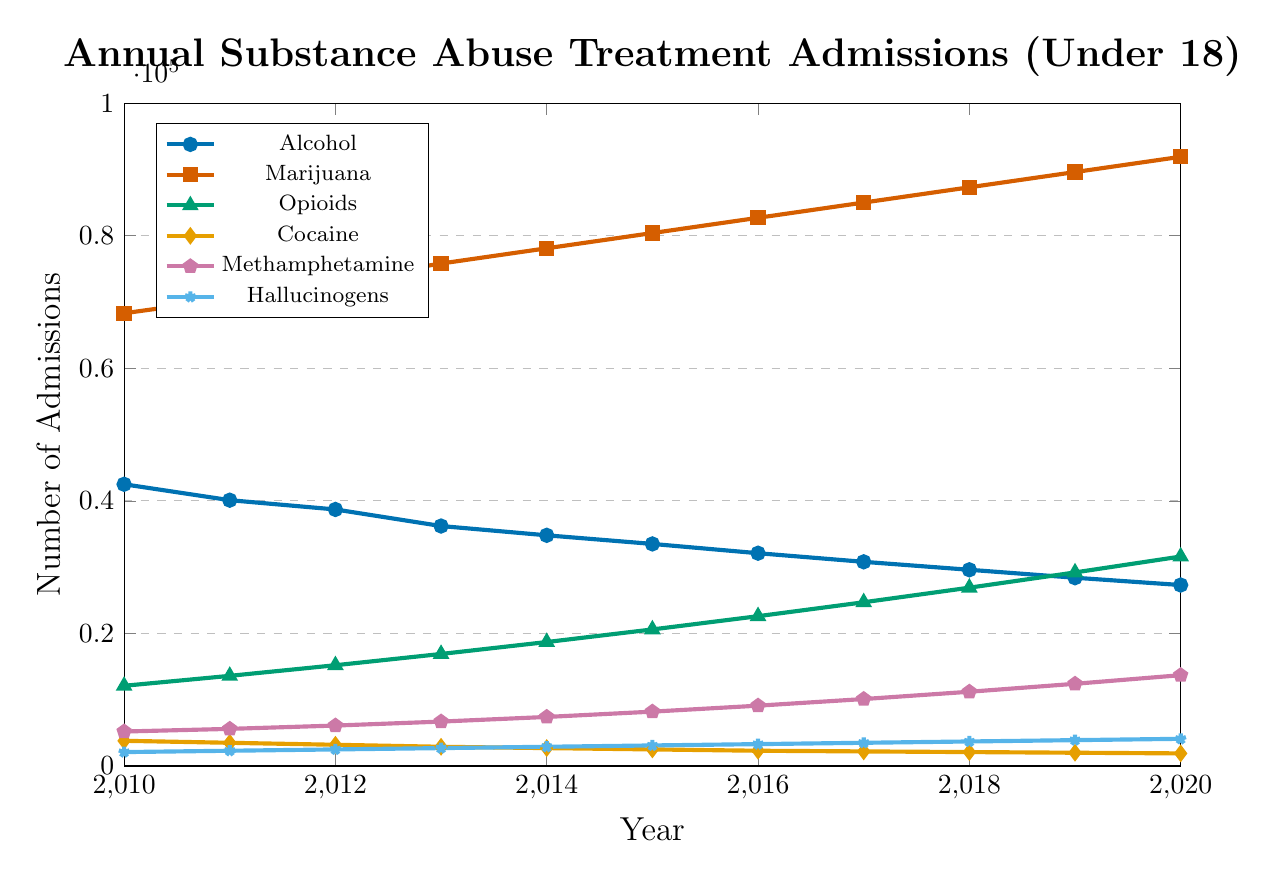What is the general trend in treatment admissions for Alcohol from 2010 to 2020? The line representing Alcohol shows a downward trend from 2010 to 2020, decreasing from 42,500 to 27,300.
Answer: Downward trend Which substance had the highest number of treatment admissions in any given year, and in which year? Marijuana had the highest number of admissions, peaking at 91,900 in 2020.
Answer: Marijuana in 2020 What is the difference in the number of treatment admissions for Methamphetamine between 2013 and 2020? In 2013, Methamphetamine admissions were 6,700. By 2020, they increased to 13,700. The difference is 13,700 - 6,700 = 7,000.
Answer: 7,000 Compare the trends for Opioids and Cocaine from 2010 to 2020. Opioids show an upward trend, increasing from 12,100 to 31,600. Conversely, Cocaine shows a downward trend, decreasing from 3,800 to 1,900.
Answer: Opioids upward, Cocaine downward In which year did Hallucinogens surpass 3,000 treatment admissions for the first time? Hallucinogens surpassed 3,000 admissions in 2013, with 3,000 admissions.
Answer: 2013 What is the total number of treatment admissions for Alcohol and Marijuana combined in 2015? Alcohol had 33,500 admissions and Marijuana had 80,400 admissions in 2015. The total is 33,500 + 80,400 = 113,900.
Answer: 113,900 How do the treatment admission trends for Alcohol and Marijuana compare? Alcohol admissions have been declining, from 42,500 in 2010 to 27,300 in 2020. Marijuana admissions have been increasing, from 68,300 in 2010 to 91,900 in 2020.
Answer: Alcohol declining, Marijuana increasing What is the average number of treatment admissions for Hallucinogens from 2010 to 2020? Sum the yearly admissions: (2,100 + 2,300 + 2,500 + 2,700 + 2,900 + 3,100 + 3,300 + 3,500 + 3,700 + 3,900 + 4,100) = 36,100. Average = 36,100 / 11 = 3,282.
Answer: 3,282 